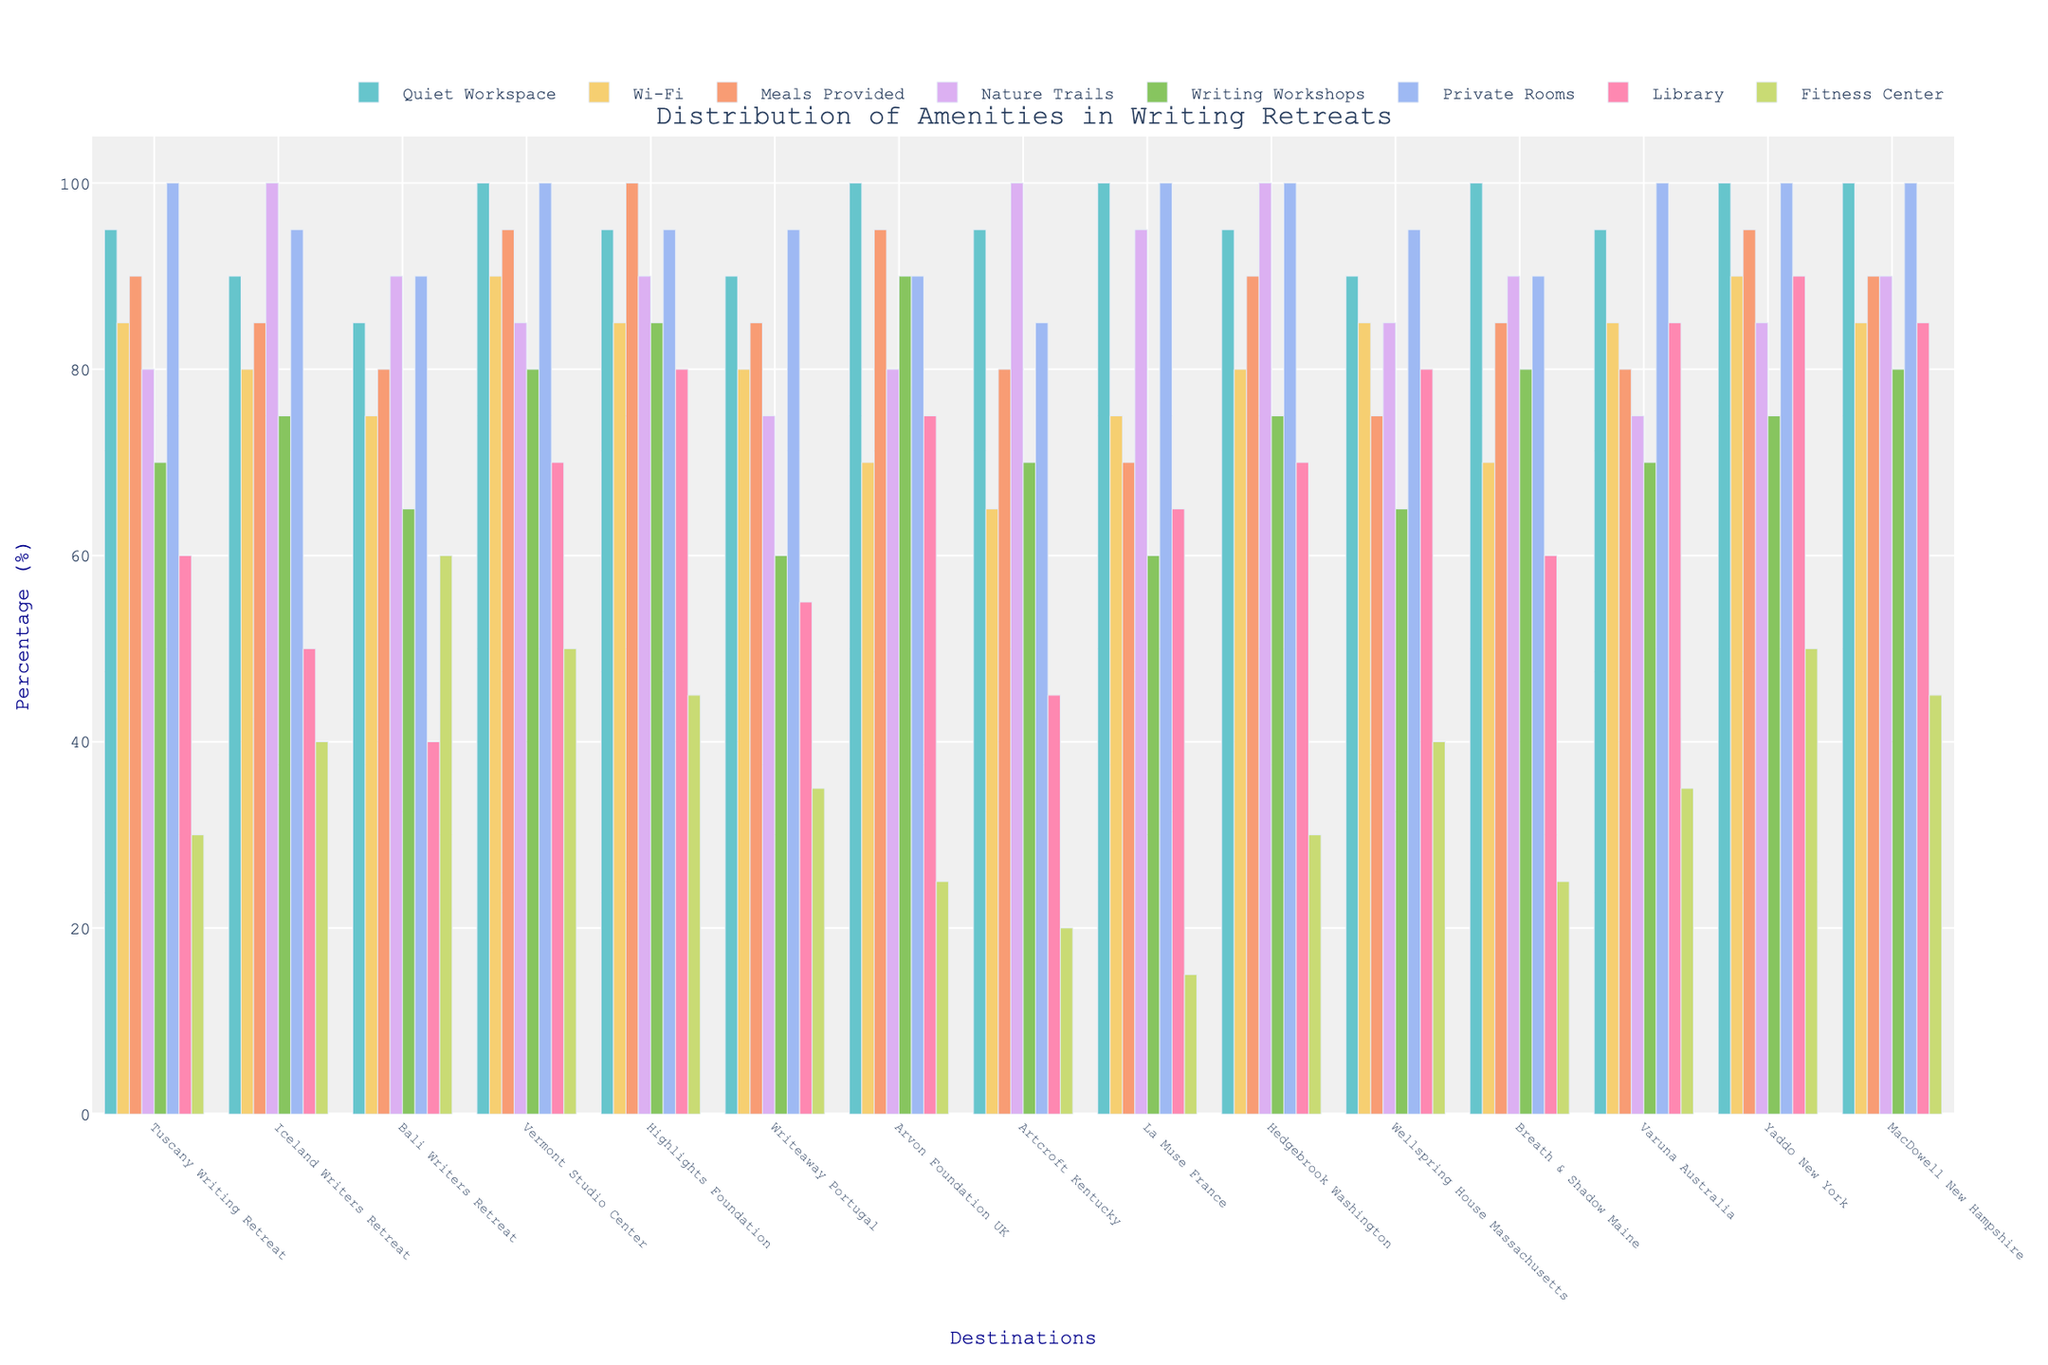what percentage of retreats offer meals provided? To determine the percentage of retreats that offer meals provided, look at the "Meals Provided" bars for all destinations and calculate the average. Add up all the provided percentages and divide by the number of destinations (15). \( (90 + 85 + 80 + 95 + 100 + 85 + 95 + 80 + 70 + 90 + 75 + 85 + 80 + 95 + 90) = 1305 \). Dividing 1305 by 15 gives 87%.
Answer: 87% Which destination offers the highest percentage of quiet workspaces? To determine the destination with the highest percentage of quiet workspaces, look at the "Quiet Workspace" bars and identify the one with the maximum height. Several destinations have this value at 100%.
Answer: Vermont Studio Center, Arvon Foundation UK, La Muse France, Yaddo New York, MacDowell New Hampshire Which destination has the lowest percentage of library amenities? To find the destination with the lowest percentage of library amenities, look for the smallest bar in the "Library" category.
Answer: Artcroft Kentucky with 45% How many destinations offer a 100% private room amenity? Count the number of bars that reach 100% height in the "Private Rooms" category. Vermont Studio Center, La Muse France, Hedgebrook Washington, MacDowell New Hampshire all offer 100% in this category.
Answer: 4 Which amenity shows the most variation in percentages across different destinations? To determine the amenity with the most variation, observe the range of heights of bars for each amenity. Compare the differences between the maximum and minimum values. “Fitness Center” seems to have the most variation with the highest at 60% and the lowest at 15%.
Answer: Fitness Center Which are the top three destinations with the highest total percentages of amenities? To find the top three destinations with the highest total percentages of all amenities, calculate the sum of the percentage values for all amenities for each destination and compare. Yaddo New York (100+90+95+85+75+100+90+50=685), Vermont Studio Center (100+90+95+85+80+100+70+50=670), and MacDowell New Hampshire (100+85+90+90+80+100+85+45=675) have the highest totals.
Answer: Yaddo New York, MacDowell New Hampshire, Vermont Studio Center 